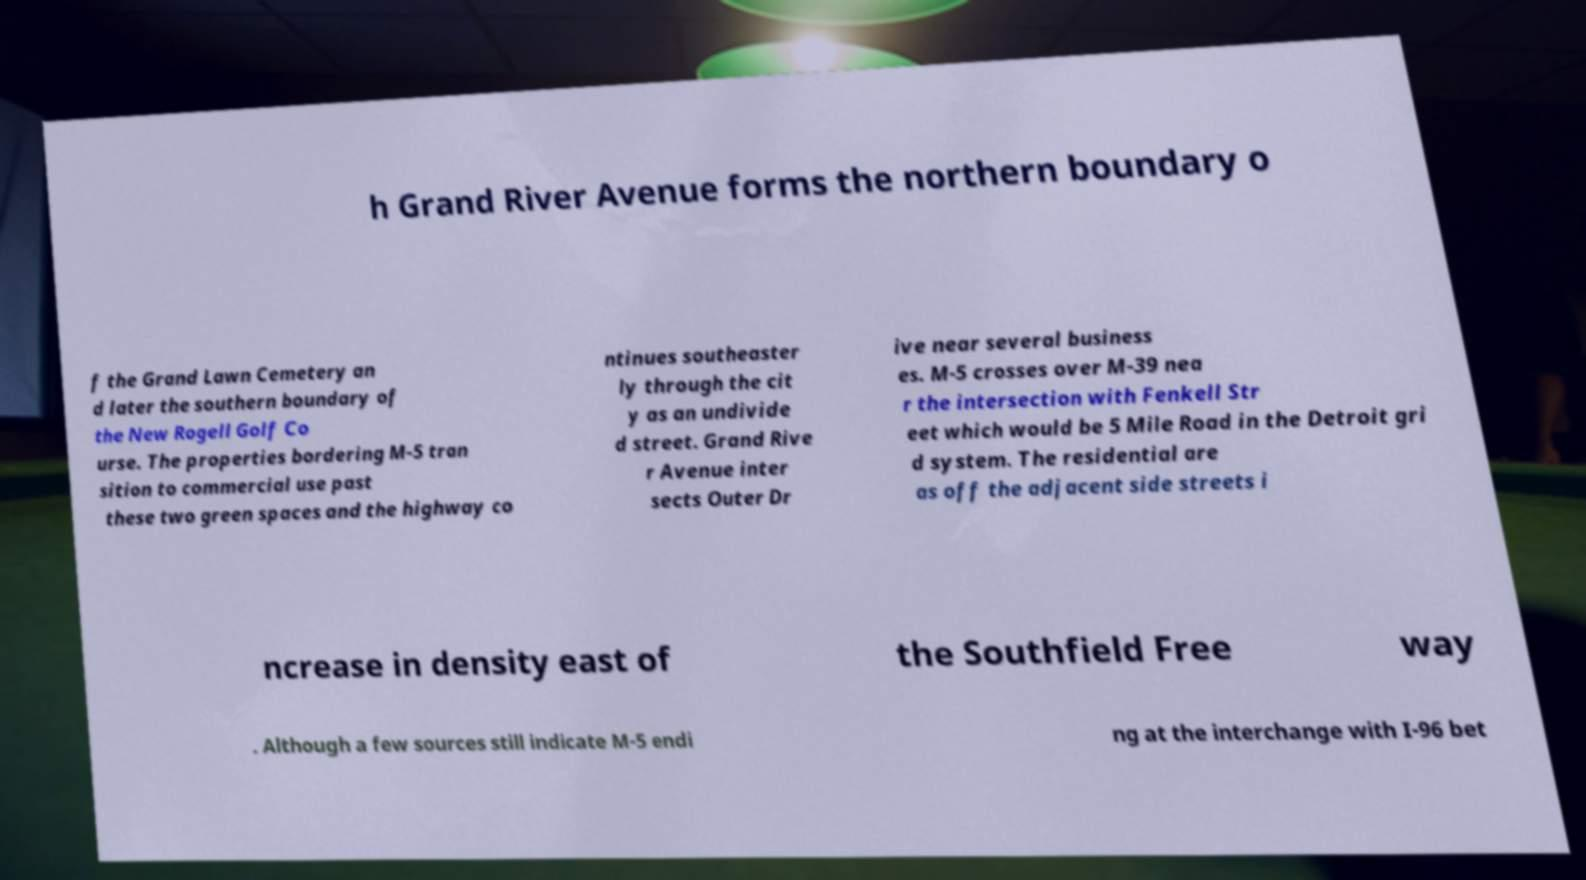For documentation purposes, I need the text within this image transcribed. Could you provide that? h Grand River Avenue forms the northern boundary o f the Grand Lawn Cemetery an d later the southern boundary of the New Rogell Golf Co urse. The properties bordering M-5 tran sition to commercial use past these two green spaces and the highway co ntinues southeaster ly through the cit y as an undivide d street. Grand Rive r Avenue inter sects Outer Dr ive near several business es. M-5 crosses over M-39 nea r the intersection with Fenkell Str eet which would be 5 Mile Road in the Detroit gri d system. The residential are as off the adjacent side streets i ncrease in density east of the Southfield Free way . Although a few sources still indicate M-5 endi ng at the interchange with I-96 bet 